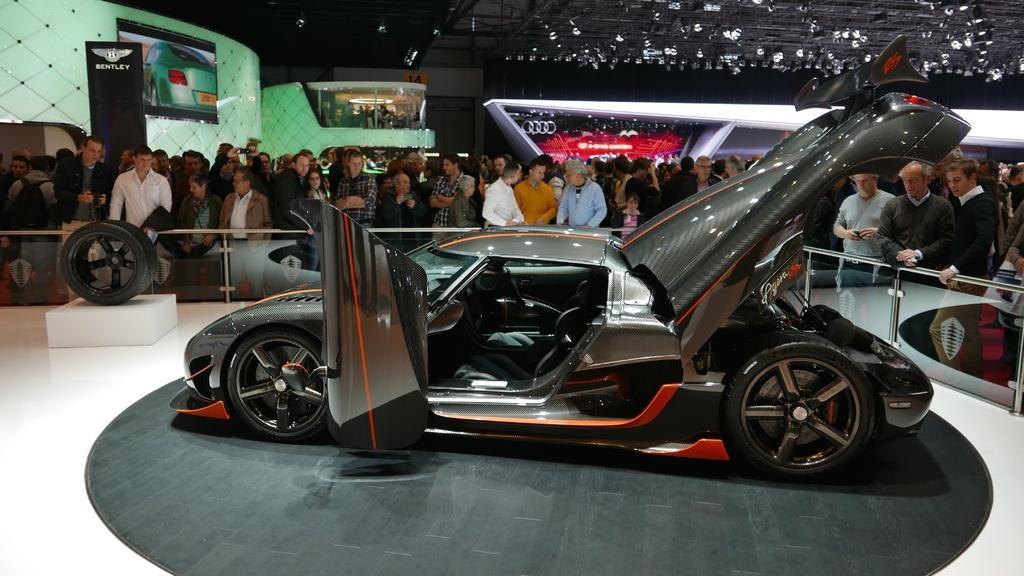In one or two sentences, can you explain what this image depicts? In the image it looks like a car expo, there is a car in the foreground and around the car there is a crowd, behind them there are logos of other vehicles. 